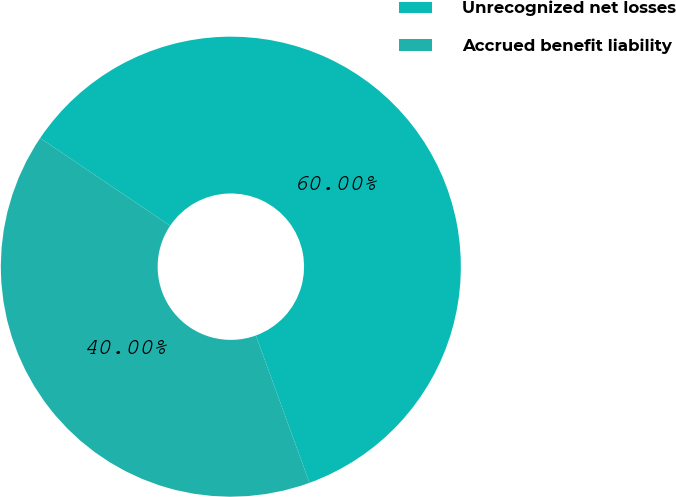Convert chart. <chart><loc_0><loc_0><loc_500><loc_500><pie_chart><fcel>Unrecognized net losses<fcel>Accrued benefit liability<nl><fcel>60.0%<fcel>40.0%<nl></chart> 